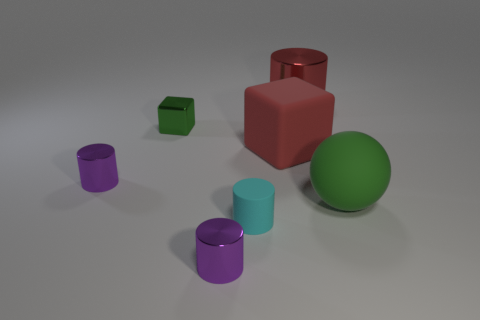Are there any brown matte objects?
Provide a succinct answer. No. Do the cylinder that is behind the red matte cube and the small shiny cube have the same size?
Provide a succinct answer. No. Are there fewer cyan cylinders than purple objects?
Ensure brevity in your answer.  Yes. The green thing that is to the right of the green object left of the big red object to the left of the big red shiny cylinder is what shape?
Provide a short and direct response. Sphere. Is there a tiny cylinder made of the same material as the large red block?
Provide a succinct answer. Yes. Does the small metallic object in front of the cyan thing have the same color as the shiny cylinder left of the shiny cube?
Offer a very short reply. Yes. Are there fewer big objects behind the matte block than red cylinders?
Your response must be concise. No. How many things are either brown objects or objects in front of the red rubber object?
Your answer should be very brief. 4. What is the color of the large thing that is the same material as the tiny green block?
Ensure brevity in your answer.  Red. What number of things are either big rubber cubes or tiny spheres?
Your answer should be compact. 1. 